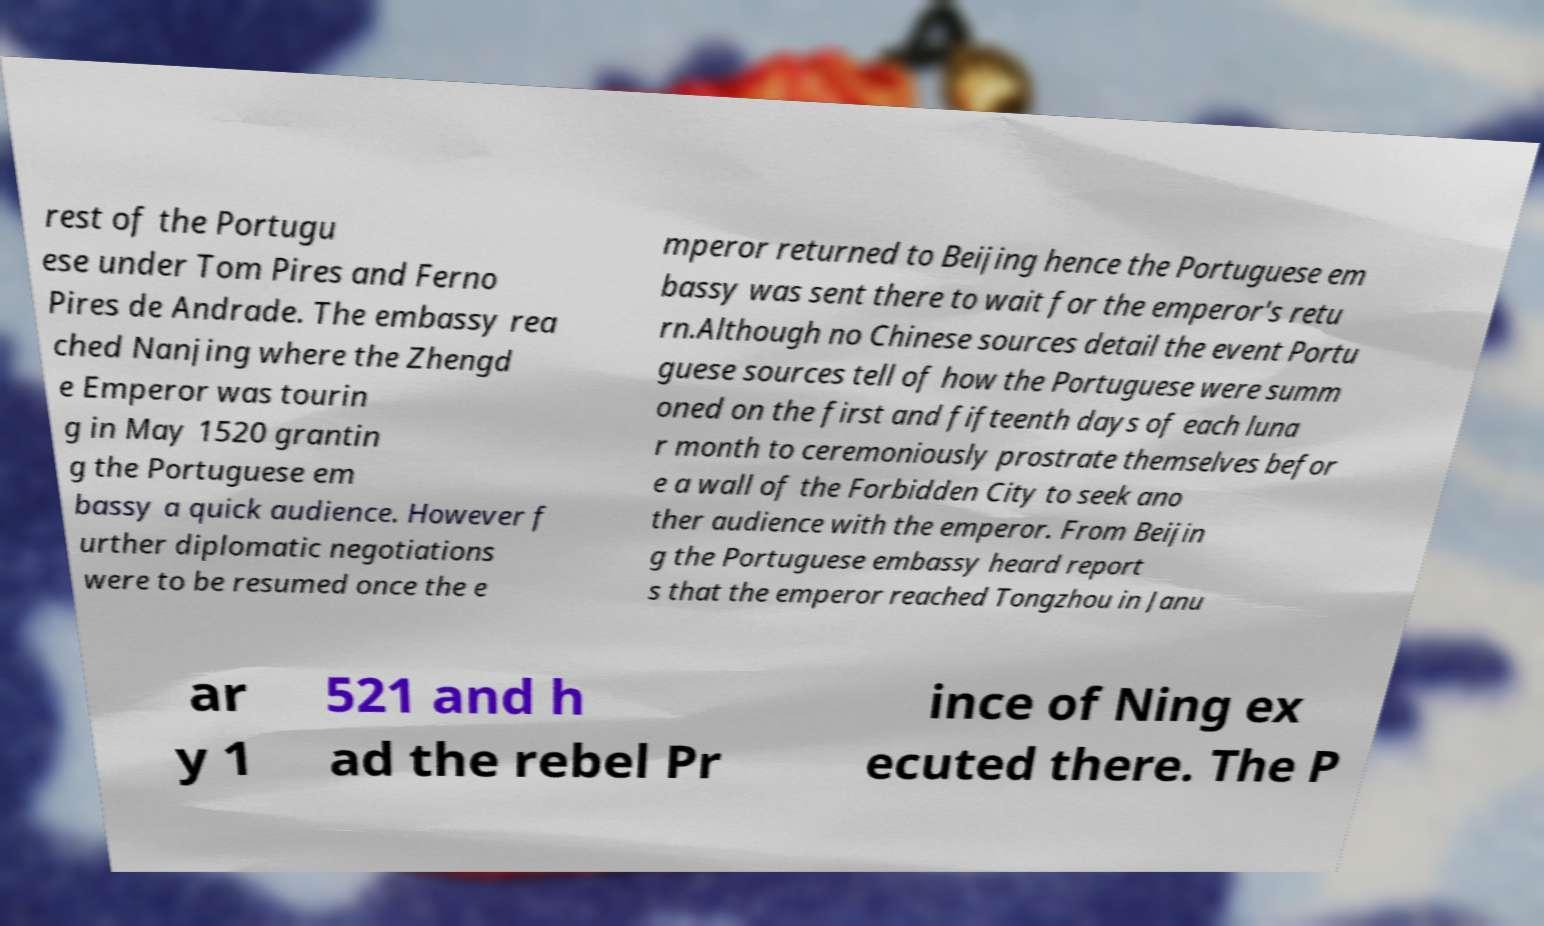There's text embedded in this image that I need extracted. Can you transcribe it verbatim? rest of the Portugu ese under Tom Pires and Ferno Pires de Andrade. The embassy rea ched Nanjing where the Zhengd e Emperor was tourin g in May 1520 grantin g the Portuguese em bassy a quick audience. However f urther diplomatic negotiations were to be resumed once the e mperor returned to Beijing hence the Portuguese em bassy was sent there to wait for the emperor's retu rn.Although no Chinese sources detail the event Portu guese sources tell of how the Portuguese were summ oned on the first and fifteenth days of each luna r month to ceremoniously prostrate themselves befor e a wall of the Forbidden City to seek ano ther audience with the emperor. From Beijin g the Portuguese embassy heard report s that the emperor reached Tongzhou in Janu ar y 1 521 and h ad the rebel Pr ince of Ning ex ecuted there. The P 